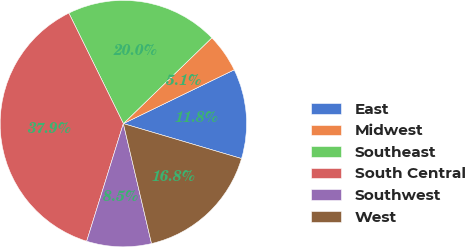<chart> <loc_0><loc_0><loc_500><loc_500><pie_chart><fcel>East<fcel>Midwest<fcel>Southeast<fcel>South Central<fcel>Southwest<fcel>West<nl><fcel>11.77%<fcel>5.06%<fcel>20.04%<fcel>37.89%<fcel>8.48%<fcel>16.75%<nl></chart> 